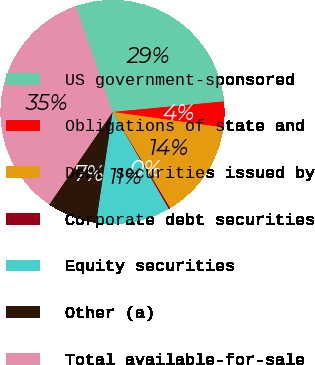Convert chart. <chart><loc_0><loc_0><loc_500><loc_500><pie_chart><fcel>US government-sponsored<fcel>Obligations of state and<fcel>Debt securities issued by<fcel>Corporate debt securities<fcel>Equity securities<fcel>Other (a)<fcel>Total available-for-sale<nl><fcel>28.79%<fcel>3.72%<fcel>14.2%<fcel>0.23%<fcel>10.7%<fcel>7.21%<fcel>35.14%<nl></chart> 